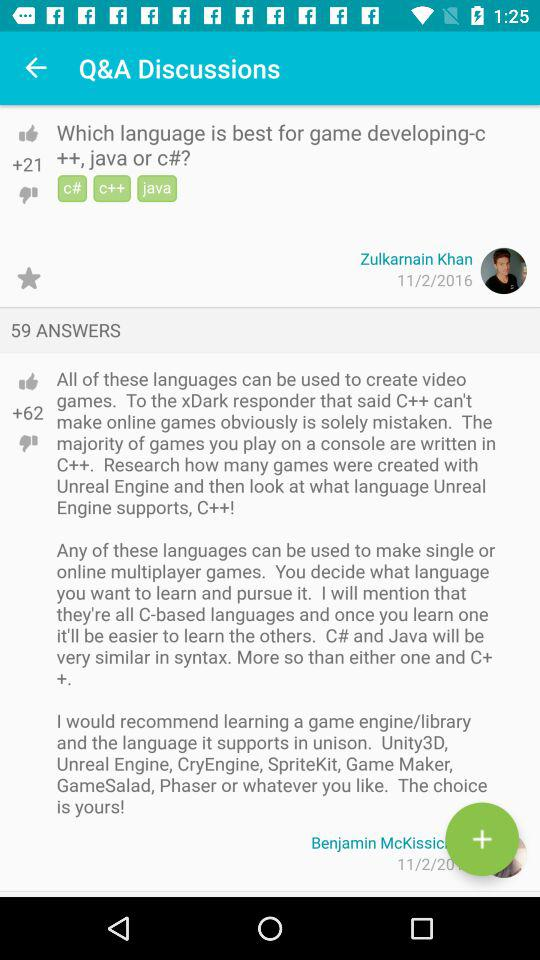What is the time? The time is 1:25. 